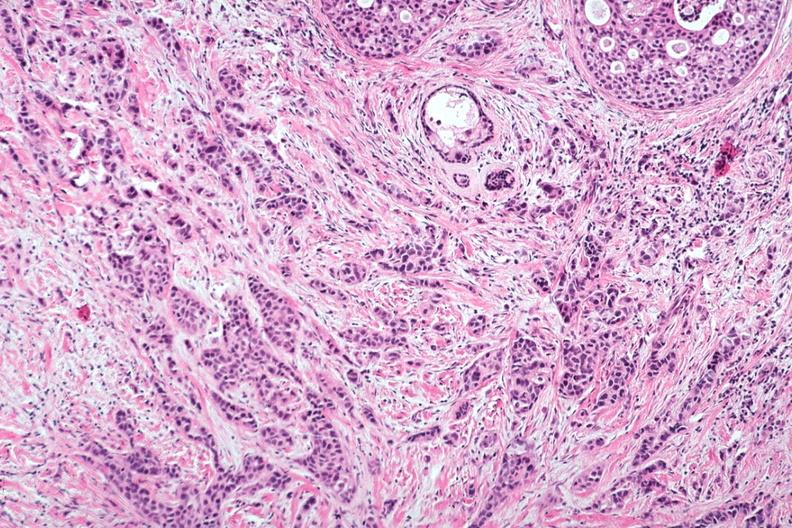what is present?
Answer the question using a single word or phrase. Breast 